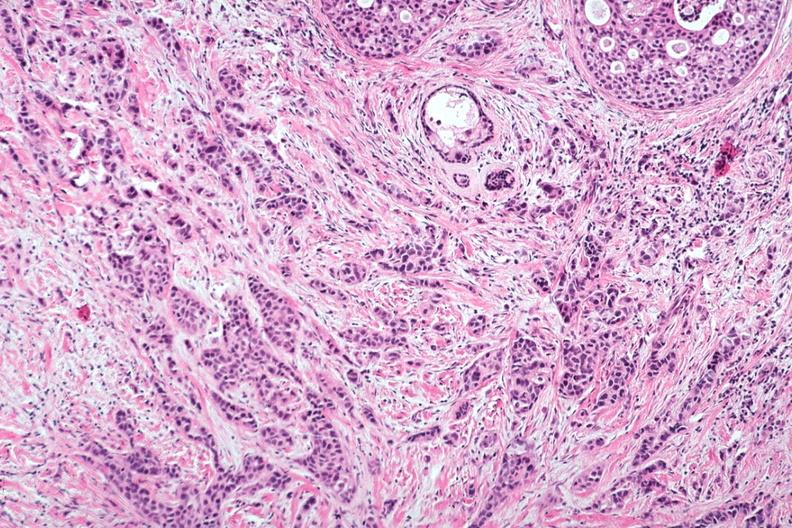what is present?
Answer the question using a single word or phrase. Breast 